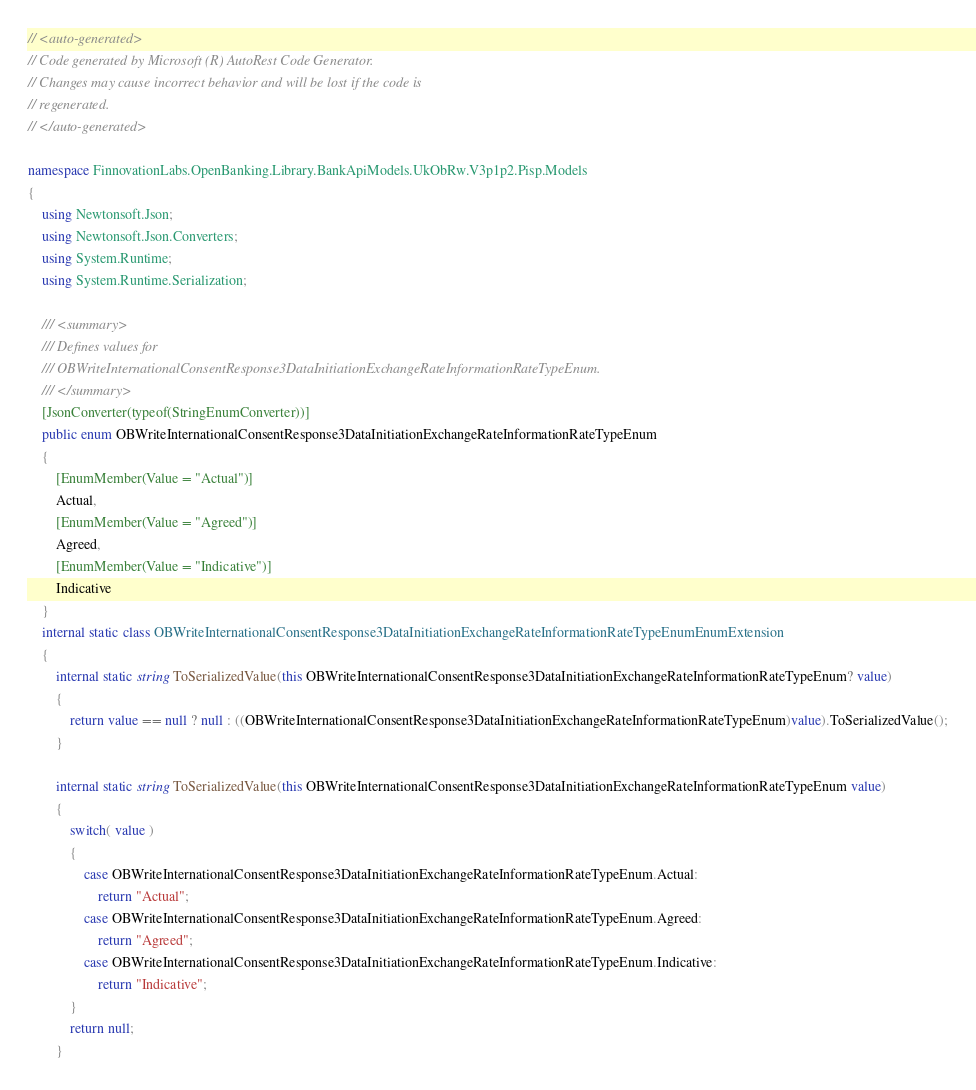Convert code to text. <code><loc_0><loc_0><loc_500><loc_500><_C#_>// <auto-generated>
// Code generated by Microsoft (R) AutoRest Code Generator.
// Changes may cause incorrect behavior and will be lost if the code is
// regenerated.
// </auto-generated>

namespace FinnovationLabs.OpenBanking.Library.BankApiModels.UkObRw.V3p1p2.Pisp.Models
{
    using Newtonsoft.Json;
    using Newtonsoft.Json.Converters;
    using System.Runtime;
    using System.Runtime.Serialization;

    /// <summary>
    /// Defines values for
    /// OBWriteInternationalConsentResponse3DataInitiationExchangeRateInformationRateTypeEnum.
    /// </summary>
    [JsonConverter(typeof(StringEnumConverter))]
    public enum OBWriteInternationalConsentResponse3DataInitiationExchangeRateInformationRateTypeEnum
    {
        [EnumMember(Value = "Actual")]
        Actual,
        [EnumMember(Value = "Agreed")]
        Agreed,
        [EnumMember(Value = "Indicative")]
        Indicative
    }
    internal static class OBWriteInternationalConsentResponse3DataInitiationExchangeRateInformationRateTypeEnumEnumExtension
    {
        internal static string ToSerializedValue(this OBWriteInternationalConsentResponse3DataInitiationExchangeRateInformationRateTypeEnum? value)
        {
            return value == null ? null : ((OBWriteInternationalConsentResponse3DataInitiationExchangeRateInformationRateTypeEnum)value).ToSerializedValue();
        }

        internal static string ToSerializedValue(this OBWriteInternationalConsentResponse3DataInitiationExchangeRateInformationRateTypeEnum value)
        {
            switch( value )
            {
                case OBWriteInternationalConsentResponse3DataInitiationExchangeRateInformationRateTypeEnum.Actual:
                    return "Actual";
                case OBWriteInternationalConsentResponse3DataInitiationExchangeRateInformationRateTypeEnum.Agreed:
                    return "Agreed";
                case OBWriteInternationalConsentResponse3DataInitiationExchangeRateInformationRateTypeEnum.Indicative:
                    return "Indicative";
            }
            return null;
        }
</code> 